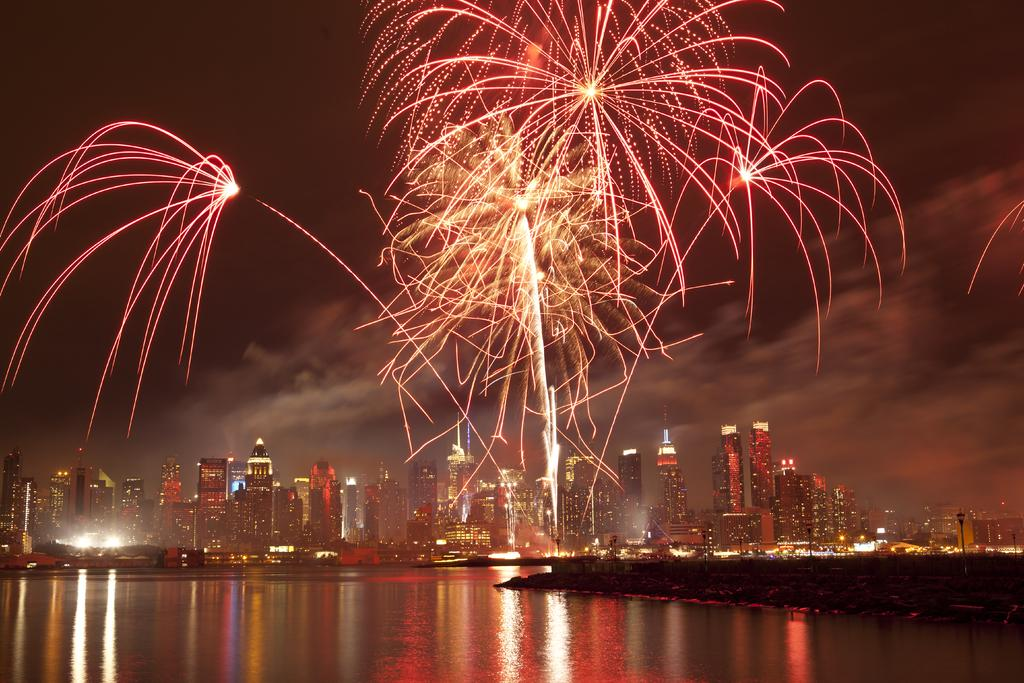What is the primary element visible in the image? There is water in the image. What else can be seen besides the water? There is ground visible in the image, as well as poles, buildings, lights, and the sky. What is happening in the background of the image? There are colorful exploding fireworks in the background of the image. What type of team is playing in the hall in the image? There is no team or hall present in the image; it features water, ground, poles, buildings, lights, the sky, and fireworks. 